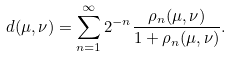<formula> <loc_0><loc_0><loc_500><loc_500>d ( \mu , \nu ) = \sum _ { n = 1 } ^ { \infty } 2 ^ { - n } \frac { \rho _ { n } ( \mu , \nu ) } { 1 + \rho _ { n } ( \mu , \nu ) } .</formula> 